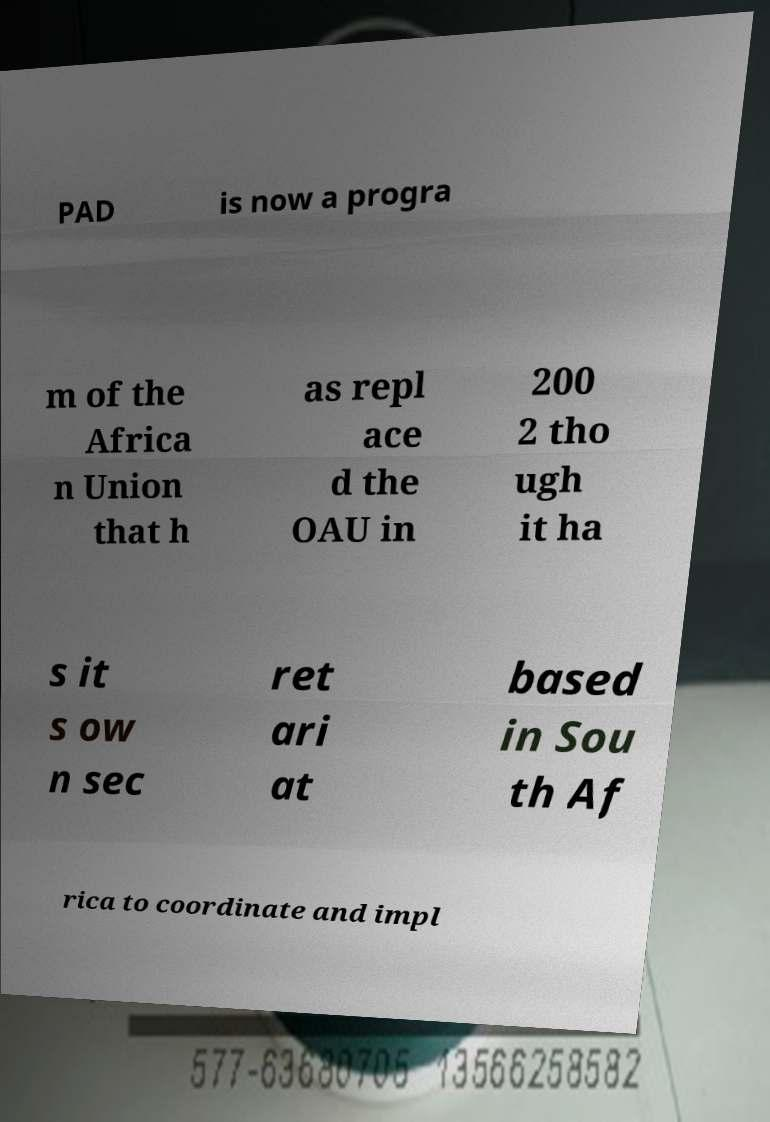Please read and relay the text visible in this image. What does it say? PAD is now a progra m of the Africa n Union that h as repl ace d the OAU in 200 2 tho ugh it ha s it s ow n sec ret ari at based in Sou th Af rica to coordinate and impl 